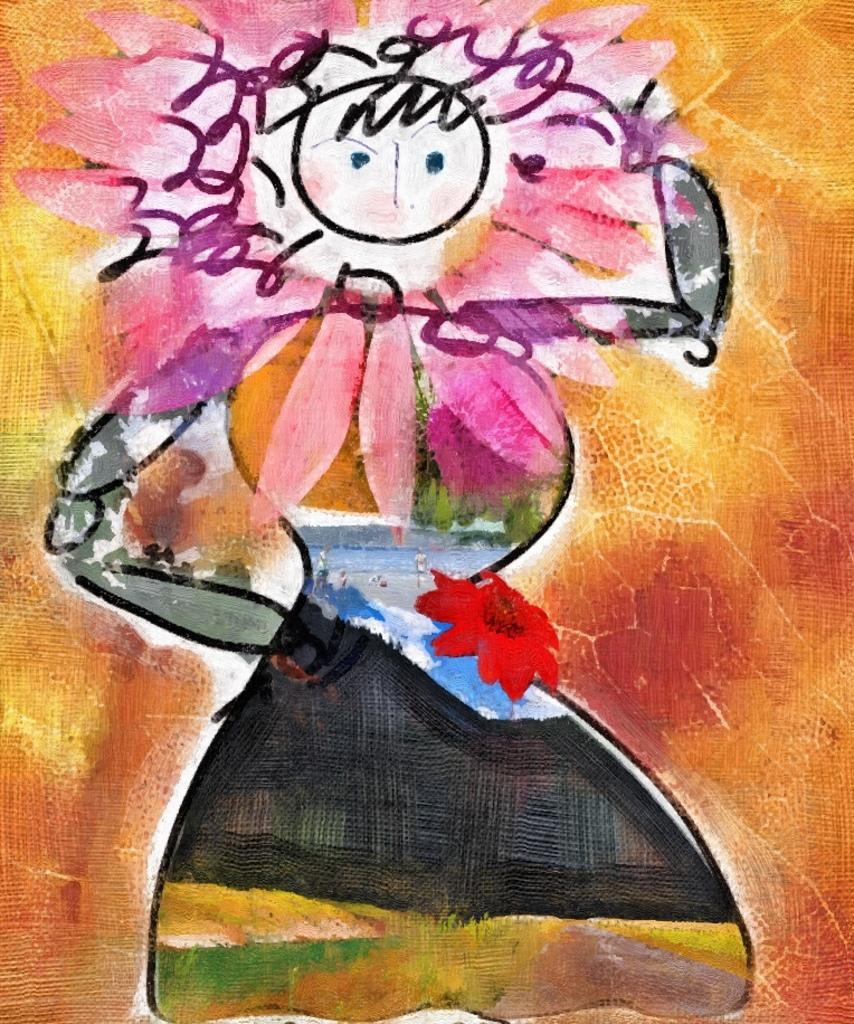What is depicted in the painting in the image? There is a painting of a person in the image. What type of plant can be seen in the image? There is a flower and leaves in the image. Can you describe the unspecified things in the image? Unfortunately, the facts provided do not specify what these unspecified things are. What type of authority does the person in the painting have over the moon in the image? There is no moon present in the image, and therefore no such authority can be determined. 